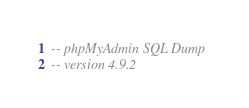Convert code to text. <code><loc_0><loc_0><loc_500><loc_500><_SQL_>-- phpMyAdmin SQL Dump
-- version 4.9.2</code> 